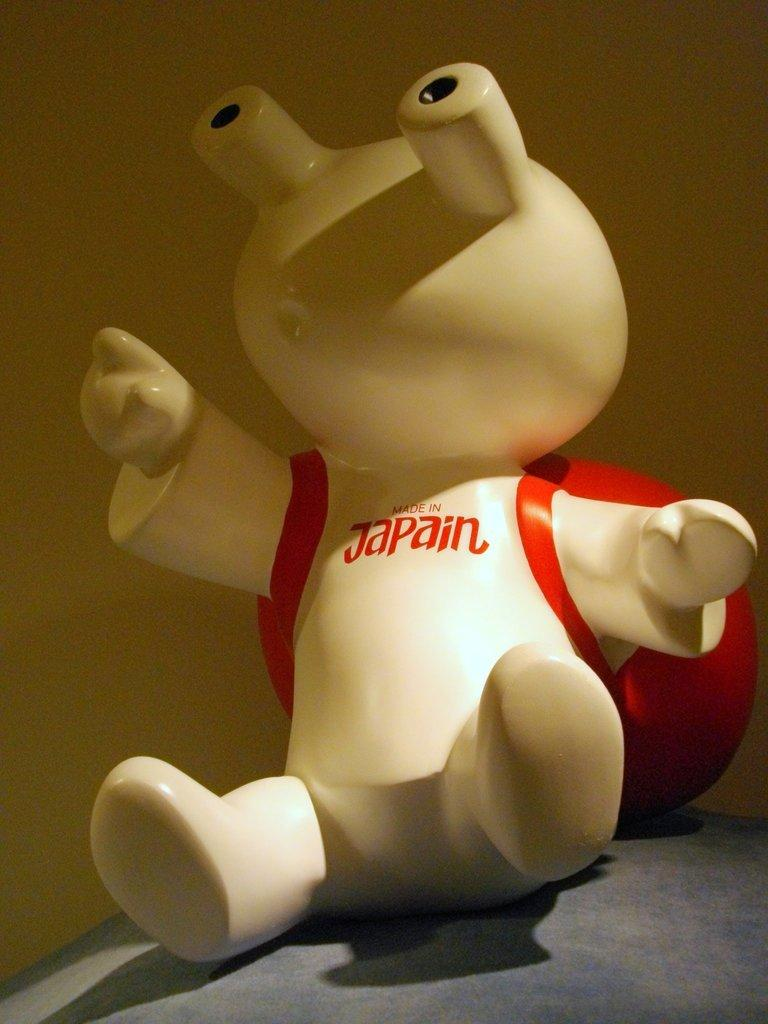What object can be seen in the picture? There is a toy in the picture. Where is the toy located? The toy is on a bed. What can be seen in the background of the picture? There is a wall visible in the background. What information is provided about the toy's origin? The toy has "made in china" written on it. What type of medical treatment is the toy receiving in the image? There is no indication in the image that the toy is receiving any medical treatment. 